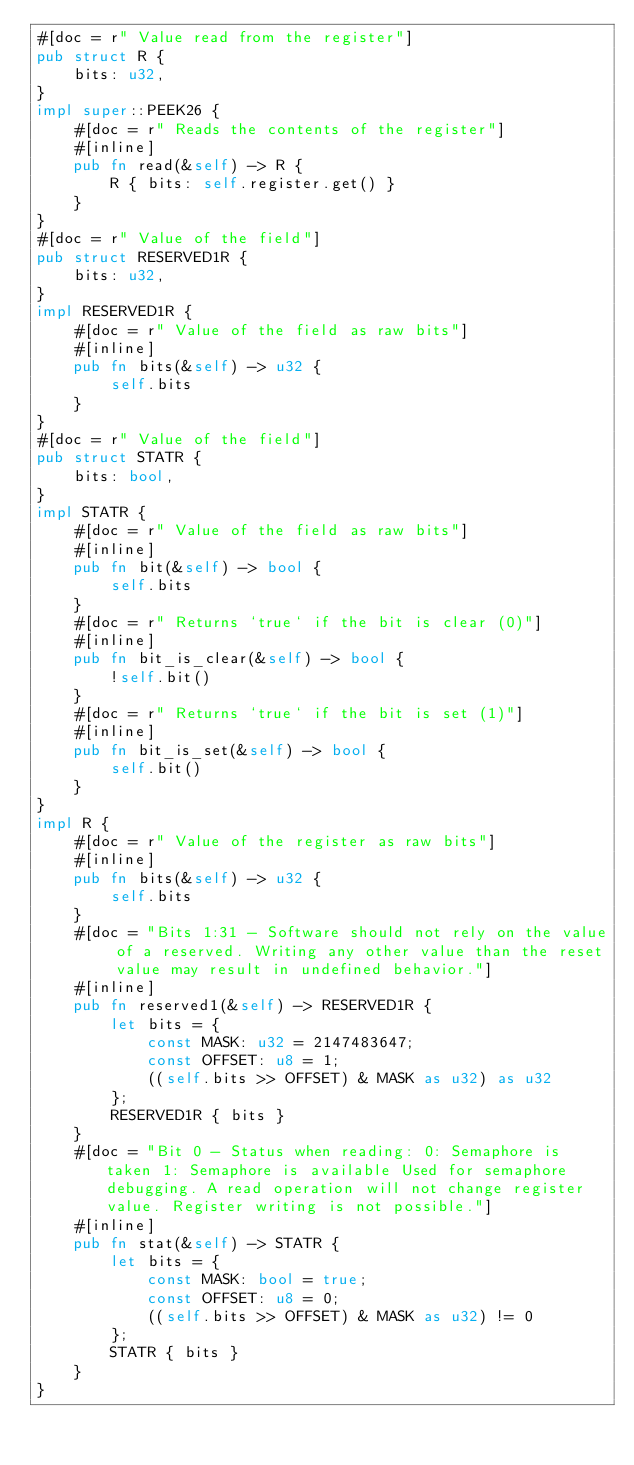Convert code to text. <code><loc_0><loc_0><loc_500><loc_500><_Rust_>#[doc = r" Value read from the register"]
pub struct R {
    bits: u32,
}
impl super::PEEK26 {
    #[doc = r" Reads the contents of the register"]
    #[inline]
    pub fn read(&self) -> R {
        R { bits: self.register.get() }
    }
}
#[doc = r" Value of the field"]
pub struct RESERVED1R {
    bits: u32,
}
impl RESERVED1R {
    #[doc = r" Value of the field as raw bits"]
    #[inline]
    pub fn bits(&self) -> u32 {
        self.bits
    }
}
#[doc = r" Value of the field"]
pub struct STATR {
    bits: bool,
}
impl STATR {
    #[doc = r" Value of the field as raw bits"]
    #[inline]
    pub fn bit(&self) -> bool {
        self.bits
    }
    #[doc = r" Returns `true` if the bit is clear (0)"]
    #[inline]
    pub fn bit_is_clear(&self) -> bool {
        !self.bit()
    }
    #[doc = r" Returns `true` if the bit is set (1)"]
    #[inline]
    pub fn bit_is_set(&self) -> bool {
        self.bit()
    }
}
impl R {
    #[doc = r" Value of the register as raw bits"]
    #[inline]
    pub fn bits(&self) -> u32 {
        self.bits
    }
    #[doc = "Bits 1:31 - Software should not rely on the value of a reserved. Writing any other value than the reset value may result in undefined behavior."]
    #[inline]
    pub fn reserved1(&self) -> RESERVED1R {
        let bits = {
            const MASK: u32 = 2147483647;
            const OFFSET: u8 = 1;
            ((self.bits >> OFFSET) & MASK as u32) as u32
        };
        RESERVED1R { bits }
    }
    #[doc = "Bit 0 - Status when reading: 0: Semaphore is taken 1: Semaphore is available Used for semaphore debugging. A read operation will not change register value. Register writing is not possible."]
    #[inline]
    pub fn stat(&self) -> STATR {
        let bits = {
            const MASK: bool = true;
            const OFFSET: u8 = 0;
            ((self.bits >> OFFSET) & MASK as u32) != 0
        };
        STATR { bits }
    }
}
</code> 